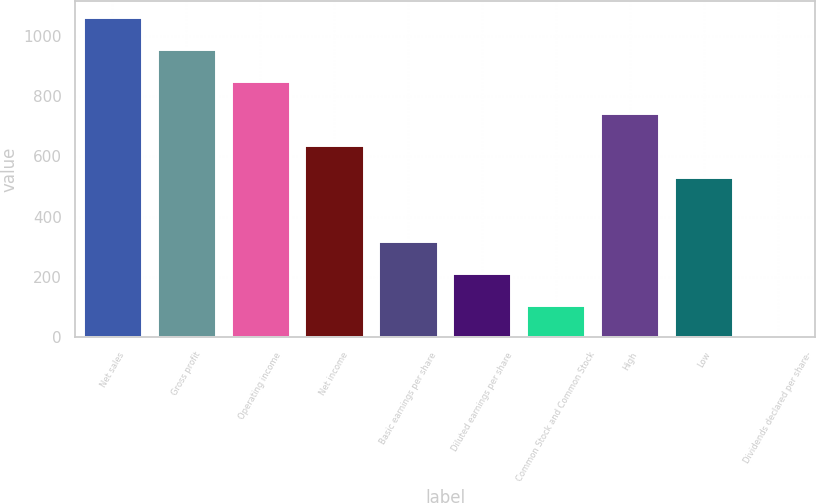Convert chart to OTSL. <chart><loc_0><loc_0><loc_500><loc_500><bar_chart><fcel>Net sales<fcel>Gross profit<fcel>Operating income<fcel>Net income<fcel>Basic earnings per share<fcel>Diluted earnings per share<fcel>Common Stock and Common Stock<fcel>High<fcel>Low<fcel>Dividends declared per share-<nl><fcel>1063.3<fcel>957.01<fcel>850.72<fcel>638.14<fcel>319.27<fcel>212.98<fcel>106.69<fcel>744.43<fcel>531.85<fcel>0.4<nl></chart> 